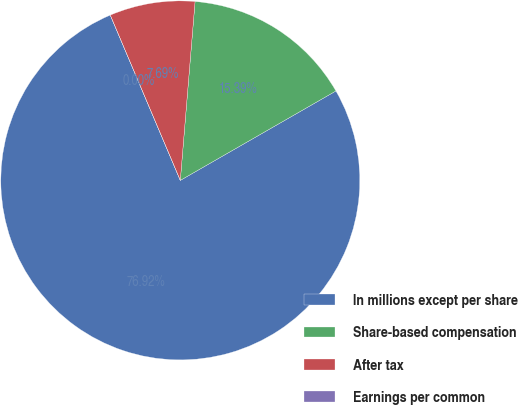<chart> <loc_0><loc_0><loc_500><loc_500><pie_chart><fcel>In millions except per share<fcel>Share-based compensation<fcel>After tax<fcel>Earnings per common<nl><fcel>76.92%<fcel>15.39%<fcel>7.69%<fcel>0.0%<nl></chart> 